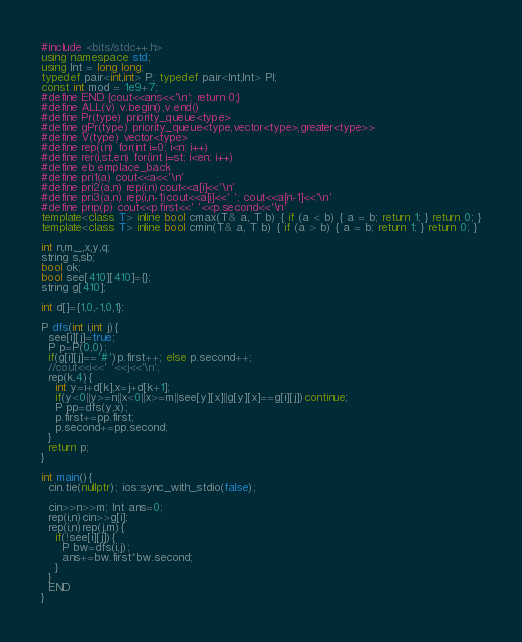Convert code to text. <code><loc_0><loc_0><loc_500><loc_500><_C++_>#include <bits/stdc++.h>
using namespace std;
using Int = long long;
typedef pair<int,int> P; typedef pair<Int,Int> Pl;
const int mod = 1e9+7;
#define END {cout<<ans<<'\n'; return 0;}
#define ALL(v) v.begin(),v.end()
#define Pr(type) priority_queue<type>
#define gPr(type) priority_queue<type,vector<type>,greater<type>>
#define V(type) vector<type>
#define rep(i,n) for(int i=0; i<n; i++)
#define rer(i,st,en) for(int i=st; i<en; i++)
#define eb emplace_back
#define pri1(a) cout<<a<<'\n'
#define pri2(a,n) rep(i,n)cout<<a[i]<<'\n'
#define pri3(a,n) rep(i,n-1)cout<<a[i]<<' '; cout<<a[n-1]<<'\n'
#define prip(p) cout<<p.first<<' '<<p.second<<'\n'
template<class T> inline bool cmax(T& a, T b) { if (a < b) { a = b; return 1; } return 0; }
template<class T> inline bool cmin(T& a, T b) { if (a > b) { a = b; return 1; } return 0; }

int n,m,_,x,y,q;
string s,sb;
bool ok;
bool see[410][410]={};
string g[410];

int d[]={1,0,-1,0,1};

P dfs(int i,int j){
  see[i][j]=true;
  P p=P(0,0);
  if(g[i][j]=='#')p.first++; else p.second++;
  //cout<<i<<' '<<j<<'\n';
  rep(k,4){
    int y=i+d[k],x=j+d[k+1];
    if(y<0||y>=n||x<0||x>=m||see[y][x]||g[y][x]==g[i][j])continue;
    P pp=dfs(y,x);
    p.first+=pp.first;
    p.second+=pp.second;
  }
  return p;
}

int main(){
  cin.tie(nullptr); ios::sync_with_stdio(false);

  cin>>n>>m; Int ans=0;
  rep(i,n)cin>>g[i];
  rep(i,n)rep(j,m){
    if(!see[i][j]){
      P bw=dfs(i,j);
      ans+=bw.first*bw.second;
    }
  }
  END
}</code> 